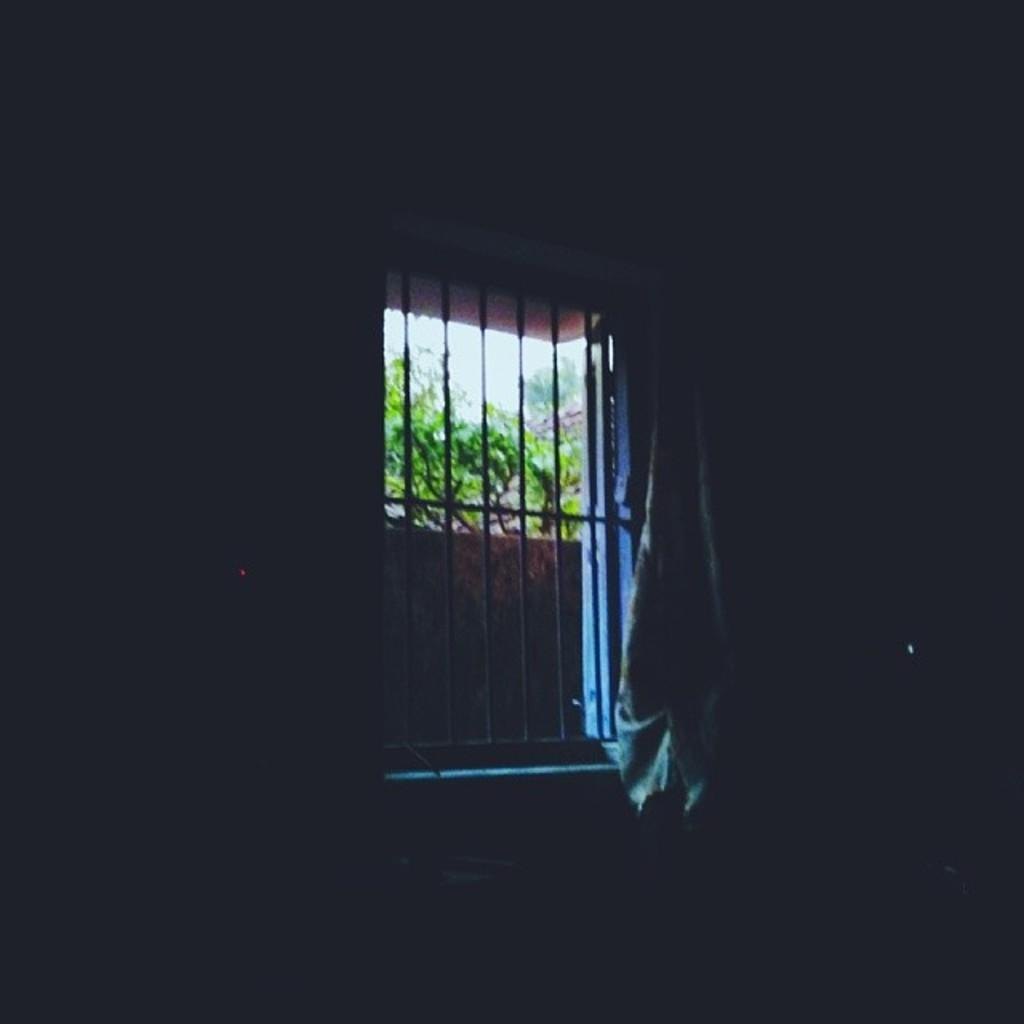What can be seen through the window in the image? There are trees outside the wall visible through the window in the image. What is located behind the window? There is a wall visible behind the window. Can you describe the natural environment outside the wall? The natural environment outside the wall includes trees. How is the mitten being distributed in the image? There is no mitten present in the image, so it cannot be distributed. 